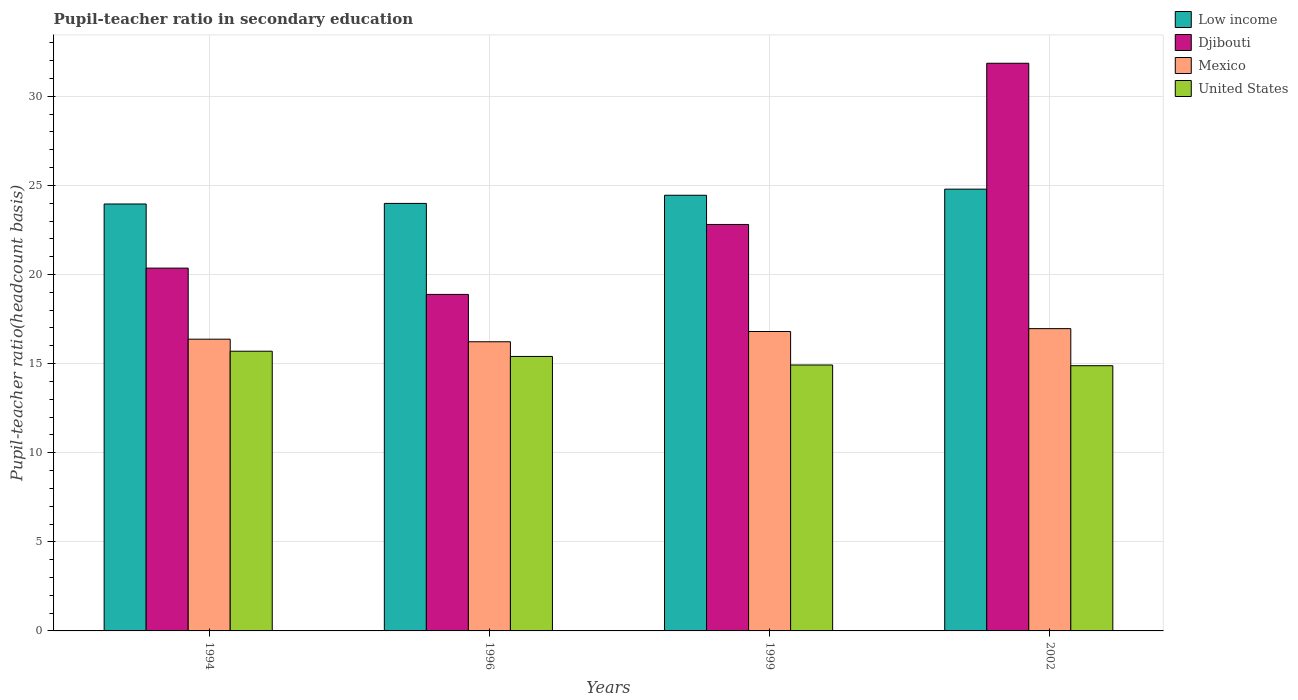How many different coloured bars are there?
Your answer should be very brief. 4. Are the number of bars per tick equal to the number of legend labels?
Provide a succinct answer. Yes. How many bars are there on the 4th tick from the left?
Your response must be concise. 4. In how many cases, is the number of bars for a given year not equal to the number of legend labels?
Your answer should be compact. 0. What is the pupil-teacher ratio in secondary education in United States in 1994?
Offer a very short reply. 15.7. Across all years, what is the maximum pupil-teacher ratio in secondary education in Mexico?
Ensure brevity in your answer.  16.96. Across all years, what is the minimum pupil-teacher ratio in secondary education in Low income?
Your answer should be compact. 23.96. In which year was the pupil-teacher ratio in secondary education in United States maximum?
Offer a terse response. 1994. What is the total pupil-teacher ratio in secondary education in United States in the graph?
Provide a short and direct response. 60.91. What is the difference between the pupil-teacher ratio in secondary education in United States in 1999 and that in 2002?
Your response must be concise. 0.04. What is the difference between the pupil-teacher ratio in secondary education in Low income in 2002 and the pupil-teacher ratio in secondary education in Djibouti in 1996?
Your response must be concise. 5.91. What is the average pupil-teacher ratio in secondary education in Low income per year?
Provide a short and direct response. 24.3. In the year 1994, what is the difference between the pupil-teacher ratio in secondary education in Djibouti and pupil-teacher ratio in secondary education in Mexico?
Your answer should be compact. 3.99. What is the ratio of the pupil-teacher ratio in secondary education in Mexico in 1994 to that in 1999?
Your response must be concise. 0.97. Is the pupil-teacher ratio in secondary education in Mexico in 1996 less than that in 1999?
Offer a terse response. Yes. Is the difference between the pupil-teacher ratio in secondary education in Djibouti in 1994 and 2002 greater than the difference between the pupil-teacher ratio in secondary education in Mexico in 1994 and 2002?
Provide a succinct answer. No. What is the difference between the highest and the second highest pupil-teacher ratio in secondary education in Djibouti?
Keep it short and to the point. 9.05. What is the difference between the highest and the lowest pupil-teacher ratio in secondary education in Low income?
Ensure brevity in your answer.  0.83. Is the sum of the pupil-teacher ratio in secondary education in Djibouti in 1994 and 1996 greater than the maximum pupil-teacher ratio in secondary education in Low income across all years?
Make the answer very short. Yes. Is it the case that in every year, the sum of the pupil-teacher ratio in secondary education in Djibouti and pupil-teacher ratio in secondary education in Low income is greater than the sum of pupil-teacher ratio in secondary education in Mexico and pupil-teacher ratio in secondary education in United States?
Ensure brevity in your answer.  Yes. What does the 4th bar from the left in 1996 represents?
Offer a very short reply. United States. What does the 3rd bar from the right in 1994 represents?
Give a very brief answer. Djibouti. Is it the case that in every year, the sum of the pupil-teacher ratio in secondary education in Mexico and pupil-teacher ratio in secondary education in Low income is greater than the pupil-teacher ratio in secondary education in United States?
Offer a very short reply. Yes. How many bars are there?
Offer a very short reply. 16. Are the values on the major ticks of Y-axis written in scientific E-notation?
Offer a very short reply. No. Does the graph contain any zero values?
Provide a succinct answer. No. Where does the legend appear in the graph?
Provide a succinct answer. Top right. What is the title of the graph?
Offer a terse response. Pupil-teacher ratio in secondary education. Does "Czech Republic" appear as one of the legend labels in the graph?
Your response must be concise. No. What is the label or title of the X-axis?
Ensure brevity in your answer.  Years. What is the label or title of the Y-axis?
Keep it short and to the point. Pupil-teacher ratio(headcount basis). What is the Pupil-teacher ratio(headcount basis) in Low income in 1994?
Give a very brief answer. 23.96. What is the Pupil-teacher ratio(headcount basis) in Djibouti in 1994?
Make the answer very short. 20.36. What is the Pupil-teacher ratio(headcount basis) in Mexico in 1994?
Your answer should be compact. 16.37. What is the Pupil-teacher ratio(headcount basis) of United States in 1994?
Offer a terse response. 15.7. What is the Pupil-teacher ratio(headcount basis) in Low income in 1996?
Keep it short and to the point. 23.99. What is the Pupil-teacher ratio(headcount basis) in Djibouti in 1996?
Offer a very short reply. 18.89. What is the Pupil-teacher ratio(headcount basis) of Mexico in 1996?
Offer a very short reply. 16.23. What is the Pupil-teacher ratio(headcount basis) in United States in 1996?
Your response must be concise. 15.4. What is the Pupil-teacher ratio(headcount basis) of Low income in 1999?
Your response must be concise. 24.45. What is the Pupil-teacher ratio(headcount basis) in Djibouti in 1999?
Provide a short and direct response. 22.81. What is the Pupil-teacher ratio(headcount basis) in Mexico in 1999?
Provide a short and direct response. 16.8. What is the Pupil-teacher ratio(headcount basis) of United States in 1999?
Offer a very short reply. 14.92. What is the Pupil-teacher ratio(headcount basis) of Low income in 2002?
Your answer should be compact. 24.79. What is the Pupil-teacher ratio(headcount basis) in Djibouti in 2002?
Offer a very short reply. 31.86. What is the Pupil-teacher ratio(headcount basis) in Mexico in 2002?
Make the answer very short. 16.96. What is the Pupil-teacher ratio(headcount basis) of United States in 2002?
Offer a terse response. 14.88. Across all years, what is the maximum Pupil-teacher ratio(headcount basis) in Low income?
Provide a succinct answer. 24.79. Across all years, what is the maximum Pupil-teacher ratio(headcount basis) in Djibouti?
Keep it short and to the point. 31.86. Across all years, what is the maximum Pupil-teacher ratio(headcount basis) in Mexico?
Your answer should be very brief. 16.96. Across all years, what is the maximum Pupil-teacher ratio(headcount basis) in United States?
Give a very brief answer. 15.7. Across all years, what is the minimum Pupil-teacher ratio(headcount basis) in Low income?
Ensure brevity in your answer.  23.96. Across all years, what is the minimum Pupil-teacher ratio(headcount basis) of Djibouti?
Provide a short and direct response. 18.89. Across all years, what is the minimum Pupil-teacher ratio(headcount basis) of Mexico?
Offer a very short reply. 16.23. Across all years, what is the minimum Pupil-teacher ratio(headcount basis) in United States?
Your answer should be very brief. 14.88. What is the total Pupil-teacher ratio(headcount basis) of Low income in the graph?
Ensure brevity in your answer.  97.19. What is the total Pupil-teacher ratio(headcount basis) of Djibouti in the graph?
Your response must be concise. 93.91. What is the total Pupil-teacher ratio(headcount basis) of Mexico in the graph?
Your response must be concise. 66.37. What is the total Pupil-teacher ratio(headcount basis) in United States in the graph?
Provide a short and direct response. 60.91. What is the difference between the Pupil-teacher ratio(headcount basis) of Low income in 1994 and that in 1996?
Ensure brevity in your answer.  -0.03. What is the difference between the Pupil-teacher ratio(headcount basis) in Djibouti in 1994 and that in 1996?
Give a very brief answer. 1.48. What is the difference between the Pupil-teacher ratio(headcount basis) in Mexico in 1994 and that in 1996?
Provide a succinct answer. 0.14. What is the difference between the Pupil-teacher ratio(headcount basis) of United States in 1994 and that in 1996?
Give a very brief answer. 0.29. What is the difference between the Pupil-teacher ratio(headcount basis) of Low income in 1994 and that in 1999?
Provide a succinct answer. -0.49. What is the difference between the Pupil-teacher ratio(headcount basis) of Djibouti in 1994 and that in 1999?
Offer a very short reply. -2.45. What is the difference between the Pupil-teacher ratio(headcount basis) in Mexico in 1994 and that in 1999?
Make the answer very short. -0.43. What is the difference between the Pupil-teacher ratio(headcount basis) in United States in 1994 and that in 1999?
Give a very brief answer. 0.77. What is the difference between the Pupil-teacher ratio(headcount basis) of Low income in 1994 and that in 2002?
Your response must be concise. -0.83. What is the difference between the Pupil-teacher ratio(headcount basis) in Djibouti in 1994 and that in 2002?
Keep it short and to the point. -11.5. What is the difference between the Pupil-teacher ratio(headcount basis) in Mexico in 1994 and that in 2002?
Your response must be concise. -0.59. What is the difference between the Pupil-teacher ratio(headcount basis) in United States in 1994 and that in 2002?
Provide a short and direct response. 0.81. What is the difference between the Pupil-teacher ratio(headcount basis) of Low income in 1996 and that in 1999?
Provide a short and direct response. -0.46. What is the difference between the Pupil-teacher ratio(headcount basis) of Djibouti in 1996 and that in 1999?
Your answer should be compact. -3.92. What is the difference between the Pupil-teacher ratio(headcount basis) of Mexico in 1996 and that in 1999?
Provide a succinct answer. -0.58. What is the difference between the Pupil-teacher ratio(headcount basis) of United States in 1996 and that in 1999?
Give a very brief answer. 0.48. What is the difference between the Pupil-teacher ratio(headcount basis) in Low income in 1996 and that in 2002?
Your answer should be compact. -0.8. What is the difference between the Pupil-teacher ratio(headcount basis) in Djibouti in 1996 and that in 2002?
Give a very brief answer. -12.97. What is the difference between the Pupil-teacher ratio(headcount basis) in Mexico in 1996 and that in 2002?
Offer a very short reply. -0.74. What is the difference between the Pupil-teacher ratio(headcount basis) in United States in 1996 and that in 2002?
Your answer should be very brief. 0.52. What is the difference between the Pupil-teacher ratio(headcount basis) of Low income in 1999 and that in 2002?
Make the answer very short. -0.34. What is the difference between the Pupil-teacher ratio(headcount basis) in Djibouti in 1999 and that in 2002?
Offer a terse response. -9.05. What is the difference between the Pupil-teacher ratio(headcount basis) of Mexico in 1999 and that in 2002?
Offer a terse response. -0.16. What is the difference between the Pupil-teacher ratio(headcount basis) in United States in 1999 and that in 2002?
Provide a succinct answer. 0.04. What is the difference between the Pupil-teacher ratio(headcount basis) in Low income in 1994 and the Pupil-teacher ratio(headcount basis) in Djibouti in 1996?
Offer a terse response. 5.07. What is the difference between the Pupil-teacher ratio(headcount basis) in Low income in 1994 and the Pupil-teacher ratio(headcount basis) in Mexico in 1996?
Provide a short and direct response. 7.73. What is the difference between the Pupil-teacher ratio(headcount basis) in Low income in 1994 and the Pupil-teacher ratio(headcount basis) in United States in 1996?
Offer a terse response. 8.56. What is the difference between the Pupil-teacher ratio(headcount basis) in Djibouti in 1994 and the Pupil-teacher ratio(headcount basis) in Mexico in 1996?
Offer a terse response. 4.13. What is the difference between the Pupil-teacher ratio(headcount basis) in Djibouti in 1994 and the Pupil-teacher ratio(headcount basis) in United States in 1996?
Offer a very short reply. 4.96. What is the difference between the Pupil-teacher ratio(headcount basis) of Mexico in 1994 and the Pupil-teacher ratio(headcount basis) of United States in 1996?
Ensure brevity in your answer.  0.97. What is the difference between the Pupil-teacher ratio(headcount basis) of Low income in 1994 and the Pupil-teacher ratio(headcount basis) of Djibouti in 1999?
Provide a short and direct response. 1.15. What is the difference between the Pupil-teacher ratio(headcount basis) of Low income in 1994 and the Pupil-teacher ratio(headcount basis) of Mexico in 1999?
Keep it short and to the point. 7.16. What is the difference between the Pupil-teacher ratio(headcount basis) in Low income in 1994 and the Pupil-teacher ratio(headcount basis) in United States in 1999?
Ensure brevity in your answer.  9.04. What is the difference between the Pupil-teacher ratio(headcount basis) of Djibouti in 1994 and the Pupil-teacher ratio(headcount basis) of Mexico in 1999?
Offer a very short reply. 3.56. What is the difference between the Pupil-teacher ratio(headcount basis) in Djibouti in 1994 and the Pupil-teacher ratio(headcount basis) in United States in 1999?
Provide a short and direct response. 5.44. What is the difference between the Pupil-teacher ratio(headcount basis) of Mexico in 1994 and the Pupil-teacher ratio(headcount basis) of United States in 1999?
Offer a terse response. 1.45. What is the difference between the Pupil-teacher ratio(headcount basis) in Low income in 1994 and the Pupil-teacher ratio(headcount basis) in Djibouti in 2002?
Your answer should be very brief. -7.9. What is the difference between the Pupil-teacher ratio(headcount basis) of Low income in 1994 and the Pupil-teacher ratio(headcount basis) of Mexico in 2002?
Your response must be concise. 7. What is the difference between the Pupil-teacher ratio(headcount basis) of Low income in 1994 and the Pupil-teacher ratio(headcount basis) of United States in 2002?
Provide a short and direct response. 9.08. What is the difference between the Pupil-teacher ratio(headcount basis) in Djibouti in 1994 and the Pupil-teacher ratio(headcount basis) in Mexico in 2002?
Provide a succinct answer. 3.4. What is the difference between the Pupil-teacher ratio(headcount basis) in Djibouti in 1994 and the Pupil-teacher ratio(headcount basis) in United States in 2002?
Your response must be concise. 5.48. What is the difference between the Pupil-teacher ratio(headcount basis) in Mexico in 1994 and the Pupil-teacher ratio(headcount basis) in United States in 2002?
Your answer should be very brief. 1.49. What is the difference between the Pupil-teacher ratio(headcount basis) of Low income in 1996 and the Pupil-teacher ratio(headcount basis) of Djibouti in 1999?
Ensure brevity in your answer.  1.18. What is the difference between the Pupil-teacher ratio(headcount basis) in Low income in 1996 and the Pupil-teacher ratio(headcount basis) in Mexico in 1999?
Offer a terse response. 7.19. What is the difference between the Pupil-teacher ratio(headcount basis) in Low income in 1996 and the Pupil-teacher ratio(headcount basis) in United States in 1999?
Provide a short and direct response. 9.07. What is the difference between the Pupil-teacher ratio(headcount basis) in Djibouti in 1996 and the Pupil-teacher ratio(headcount basis) in Mexico in 1999?
Provide a short and direct response. 2.08. What is the difference between the Pupil-teacher ratio(headcount basis) of Djibouti in 1996 and the Pupil-teacher ratio(headcount basis) of United States in 1999?
Offer a terse response. 3.96. What is the difference between the Pupil-teacher ratio(headcount basis) of Mexico in 1996 and the Pupil-teacher ratio(headcount basis) of United States in 1999?
Keep it short and to the point. 1.3. What is the difference between the Pupil-teacher ratio(headcount basis) in Low income in 1996 and the Pupil-teacher ratio(headcount basis) in Djibouti in 2002?
Ensure brevity in your answer.  -7.87. What is the difference between the Pupil-teacher ratio(headcount basis) in Low income in 1996 and the Pupil-teacher ratio(headcount basis) in Mexico in 2002?
Offer a very short reply. 7.03. What is the difference between the Pupil-teacher ratio(headcount basis) of Low income in 1996 and the Pupil-teacher ratio(headcount basis) of United States in 2002?
Your response must be concise. 9.11. What is the difference between the Pupil-teacher ratio(headcount basis) in Djibouti in 1996 and the Pupil-teacher ratio(headcount basis) in Mexico in 2002?
Your answer should be very brief. 1.92. What is the difference between the Pupil-teacher ratio(headcount basis) of Djibouti in 1996 and the Pupil-teacher ratio(headcount basis) of United States in 2002?
Keep it short and to the point. 4. What is the difference between the Pupil-teacher ratio(headcount basis) of Mexico in 1996 and the Pupil-teacher ratio(headcount basis) of United States in 2002?
Provide a succinct answer. 1.34. What is the difference between the Pupil-teacher ratio(headcount basis) of Low income in 1999 and the Pupil-teacher ratio(headcount basis) of Djibouti in 2002?
Make the answer very short. -7.41. What is the difference between the Pupil-teacher ratio(headcount basis) of Low income in 1999 and the Pupil-teacher ratio(headcount basis) of Mexico in 2002?
Your answer should be very brief. 7.49. What is the difference between the Pupil-teacher ratio(headcount basis) of Low income in 1999 and the Pupil-teacher ratio(headcount basis) of United States in 2002?
Your response must be concise. 9.57. What is the difference between the Pupil-teacher ratio(headcount basis) of Djibouti in 1999 and the Pupil-teacher ratio(headcount basis) of Mexico in 2002?
Keep it short and to the point. 5.85. What is the difference between the Pupil-teacher ratio(headcount basis) of Djibouti in 1999 and the Pupil-teacher ratio(headcount basis) of United States in 2002?
Give a very brief answer. 7.93. What is the difference between the Pupil-teacher ratio(headcount basis) of Mexico in 1999 and the Pupil-teacher ratio(headcount basis) of United States in 2002?
Your answer should be compact. 1.92. What is the average Pupil-teacher ratio(headcount basis) in Low income per year?
Provide a succinct answer. 24.3. What is the average Pupil-teacher ratio(headcount basis) of Djibouti per year?
Keep it short and to the point. 23.48. What is the average Pupil-teacher ratio(headcount basis) of Mexico per year?
Make the answer very short. 16.59. What is the average Pupil-teacher ratio(headcount basis) of United States per year?
Ensure brevity in your answer.  15.23. In the year 1994, what is the difference between the Pupil-teacher ratio(headcount basis) in Low income and Pupil-teacher ratio(headcount basis) in Djibouti?
Your response must be concise. 3.6. In the year 1994, what is the difference between the Pupil-teacher ratio(headcount basis) of Low income and Pupil-teacher ratio(headcount basis) of Mexico?
Your answer should be very brief. 7.59. In the year 1994, what is the difference between the Pupil-teacher ratio(headcount basis) in Low income and Pupil-teacher ratio(headcount basis) in United States?
Give a very brief answer. 8.26. In the year 1994, what is the difference between the Pupil-teacher ratio(headcount basis) of Djibouti and Pupil-teacher ratio(headcount basis) of Mexico?
Offer a terse response. 3.99. In the year 1994, what is the difference between the Pupil-teacher ratio(headcount basis) in Djibouti and Pupil-teacher ratio(headcount basis) in United States?
Give a very brief answer. 4.66. In the year 1994, what is the difference between the Pupil-teacher ratio(headcount basis) in Mexico and Pupil-teacher ratio(headcount basis) in United States?
Offer a terse response. 0.67. In the year 1996, what is the difference between the Pupil-teacher ratio(headcount basis) of Low income and Pupil-teacher ratio(headcount basis) of Djibouti?
Give a very brief answer. 5.11. In the year 1996, what is the difference between the Pupil-teacher ratio(headcount basis) in Low income and Pupil-teacher ratio(headcount basis) in Mexico?
Your answer should be very brief. 7.76. In the year 1996, what is the difference between the Pupil-teacher ratio(headcount basis) of Low income and Pupil-teacher ratio(headcount basis) of United States?
Ensure brevity in your answer.  8.59. In the year 1996, what is the difference between the Pupil-teacher ratio(headcount basis) in Djibouti and Pupil-teacher ratio(headcount basis) in Mexico?
Offer a terse response. 2.66. In the year 1996, what is the difference between the Pupil-teacher ratio(headcount basis) in Djibouti and Pupil-teacher ratio(headcount basis) in United States?
Offer a very short reply. 3.48. In the year 1996, what is the difference between the Pupil-teacher ratio(headcount basis) of Mexico and Pupil-teacher ratio(headcount basis) of United States?
Your answer should be very brief. 0.82. In the year 1999, what is the difference between the Pupil-teacher ratio(headcount basis) in Low income and Pupil-teacher ratio(headcount basis) in Djibouti?
Give a very brief answer. 1.64. In the year 1999, what is the difference between the Pupil-teacher ratio(headcount basis) in Low income and Pupil-teacher ratio(headcount basis) in Mexico?
Provide a succinct answer. 7.65. In the year 1999, what is the difference between the Pupil-teacher ratio(headcount basis) of Low income and Pupil-teacher ratio(headcount basis) of United States?
Offer a very short reply. 9.53. In the year 1999, what is the difference between the Pupil-teacher ratio(headcount basis) of Djibouti and Pupil-teacher ratio(headcount basis) of Mexico?
Provide a short and direct response. 6.01. In the year 1999, what is the difference between the Pupil-teacher ratio(headcount basis) in Djibouti and Pupil-teacher ratio(headcount basis) in United States?
Offer a very short reply. 7.89. In the year 1999, what is the difference between the Pupil-teacher ratio(headcount basis) of Mexico and Pupil-teacher ratio(headcount basis) of United States?
Offer a very short reply. 1.88. In the year 2002, what is the difference between the Pupil-teacher ratio(headcount basis) of Low income and Pupil-teacher ratio(headcount basis) of Djibouti?
Offer a very short reply. -7.07. In the year 2002, what is the difference between the Pupil-teacher ratio(headcount basis) in Low income and Pupil-teacher ratio(headcount basis) in Mexico?
Keep it short and to the point. 7.83. In the year 2002, what is the difference between the Pupil-teacher ratio(headcount basis) in Low income and Pupil-teacher ratio(headcount basis) in United States?
Provide a succinct answer. 9.91. In the year 2002, what is the difference between the Pupil-teacher ratio(headcount basis) of Djibouti and Pupil-teacher ratio(headcount basis) of Mexico?
Provide a succinct answer. 14.89. In the year 2002, what is the difference between the Pupil-teacher ratio(headcount basis) of Djibouti and Pupil-teacher ratio(headcount basis) of United States?
Give a very brief answer. 16.97. In the year 2002, what is the difference between the Pupil-teacher ratio(headcount basis) in Mexico and Pupil-teacher ratio(headcount basis) in United States?
Offer a terse response. 2.08. What is the ratio of the Pupil-teacher ratio(headcount basis) of Low income in 1994 to that in 1996?
Offer a very short reply. 1. What is the ratio of the Pupil-teacher ratio(headcount basis) of Djibouti in 1994 to that in 1996?
Provide a succinct answer. 1.08. What is the ratio of the Pupil-teacher ratio(headcount basis) of Mexico in 1994 to that in 1996?
Provide a succinct answer. 1.01. What is the ratio of the Pupil-teacher ratio(headcount basis) of United States in 1994 to that in 1996?
Provide a succinct answer. 1.02. What is the ratio of the Pupil-teacher ratio(headcount basis) in Low income in 1994 to that in 1999?
Keep it short and to the point. 0.98. What is the ratio of the Pupil-teacher ratio(headcount basis) in Djibouti in 1994 to that in 1999?
Offer a terse response. 0.89. What is the ratio of the Pupil-teacher ratio(headcount basis) of Mexico in 1994 to that in 1999?
Ensure brevity in your answer.  0.97. What is the ratio of the Pupil-teacher ratio(headcount basis) in United States in 1994 to that in 1999?
Provide a short and direct response. 1.05. What is the ratio of the Pupil-teacher ratio(headcount basis) of Low income in 1994 to that in 2002?
Offer a terse response. 0.97. What is the ratio of the Pupil-teacher ratio(headcount basis) in Djibouti in 1994 to that in 2002?
Ensure brevity in your answer.  0.64. What is the ratio of the Pupil-teacher ratio(headcount basis) of Mexico in 1994 to that in 2002?
Offer a very short reply. 0.97. What is the ratio of the Pupil-teacher ratio(headcount basis) in United States in 1994 to that in 2002?
Make the answer very short. 1.05. What is the ratio of the Pupil-teacher ratio(headcount basis) of Low income in 1996 to that in 1999?
Your response must be concise. 0.98. What is the ratio of the Pupil-teacher ratio(headcount basis) in Djibouti in 1996 to that in 1999?
Ensure brevity in your answer.  0.83. What is the ratio of the Pupil-teacher ratio(headcount basis) in Mexico in 1996 to that in 1999?
Your response must be concise. 0.97. What is the ratio of the Pupil-teacher ratio(headcount basis) of United States in 1996 to that in 1999?
Offer a very short reply. 1.03. What is the ratio of the Pupil-teacher ratio(headcount basis) of Djibouti in 1996 to that in 2002?
Offer a terse response. 0.59. What is the ratio of the Pupil-teacher ratio(headcount basis) in Mexico in 1996 to that in 2002?
Your answer should be very brief. 0.96. What is the ratio of the Pupil-teacher ratio(headcount basis) of United States in 1996 to that in 2002?
Your answer should be compact. 1.03. What is the ratio of the Pupil-teacher ratio(headcount basis) of Low income in 1999 to that in 2002?
Give a very brief answer. 0.99. What is the ratio of the Pupil-teacher ratio(headcount basis) of Djibouti in 1999 to that in 2002?
Your answer should be compact. 0.72. What is the ratio of the Pupil-teacher ratio(headcount basis) of Mexico in 1999 to that in 2002?
Provide a succinct answer. 0.99. What is the ratio of the Pupil-teacher ratio(headcount basis) in United States in 1999 to that in 2002?
Give a very brief answer. 1. What is the difference between the highest and the second highest Pupil-teacher ratio(headcount basis) of Low income?
Keep it short and to the point. 0.34. What is the difference between the highest and the second highest Pupil-teacher ratio(headcount basis) of Djibouti?
Provide a short and direct response. 9.05. What is the difference between the highest and the second highest Pupil-teacher ratio(headcount basis) in Mexico?
Keep it short and to the point. 0.16. What is the difference between the highest and the second highest Pupil-teacher ratio(headcount basis) of United States?
Offer a terse response. 0.29. What is the difference between the highest and the lowest Pupil-teacher ratio(headcount basis) in Low income?
Provide a short and direct response. 0.83. What is the difference between the highest and the lowest Pupil-teacher ratio(headcount basis) of Djibouti?
Your answer should be compact. 12.97. What is the difference between the highest and the lowest Pupil-teacher ratio(headcount basis) in Mexico?
Offer a very short reply. 0.74. What is the difference between the highest and the lowest Pupil-teacher ratio(headcount basis) in United States?
Offer a terse response. 0.81. 